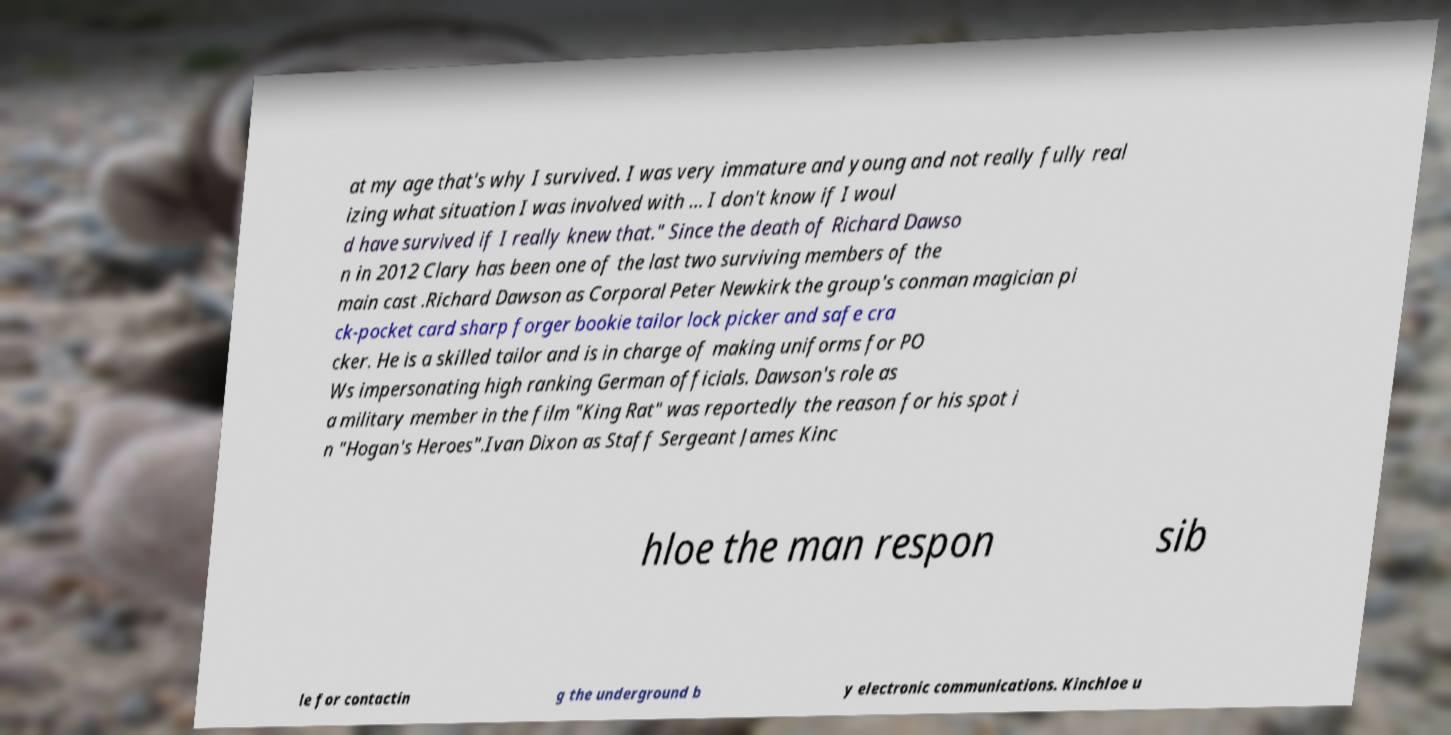Please read and relay the text visible in this image. What does it say? at my age that's why I survived. I was very immature and young and not really fully real izing what situation I was involved with ... I don't know if I woul d have survived if I really knew that." Since the death of Richard Dawso n in 2012 Clary has been one of the last two surviving members of the main cast .Richard Dawson as Corporal Peter Newkirk the group's conman magician pi ck-pocket card sharp forger bookie tailor lock picker and safe cra cker. He is a skilled tailor and is in charge of making uniforms for PO Ws impersonating high ranking German officials. Dawson's role as a military member in the film "King Rat" was reportedly the reason for his spot i n "Hogan's Heroes".Ivan Dixon as Staff Sergeant James Kinc hloe the man respon sib le for contactin g the underground b y electronic communications. Kinchloe u 